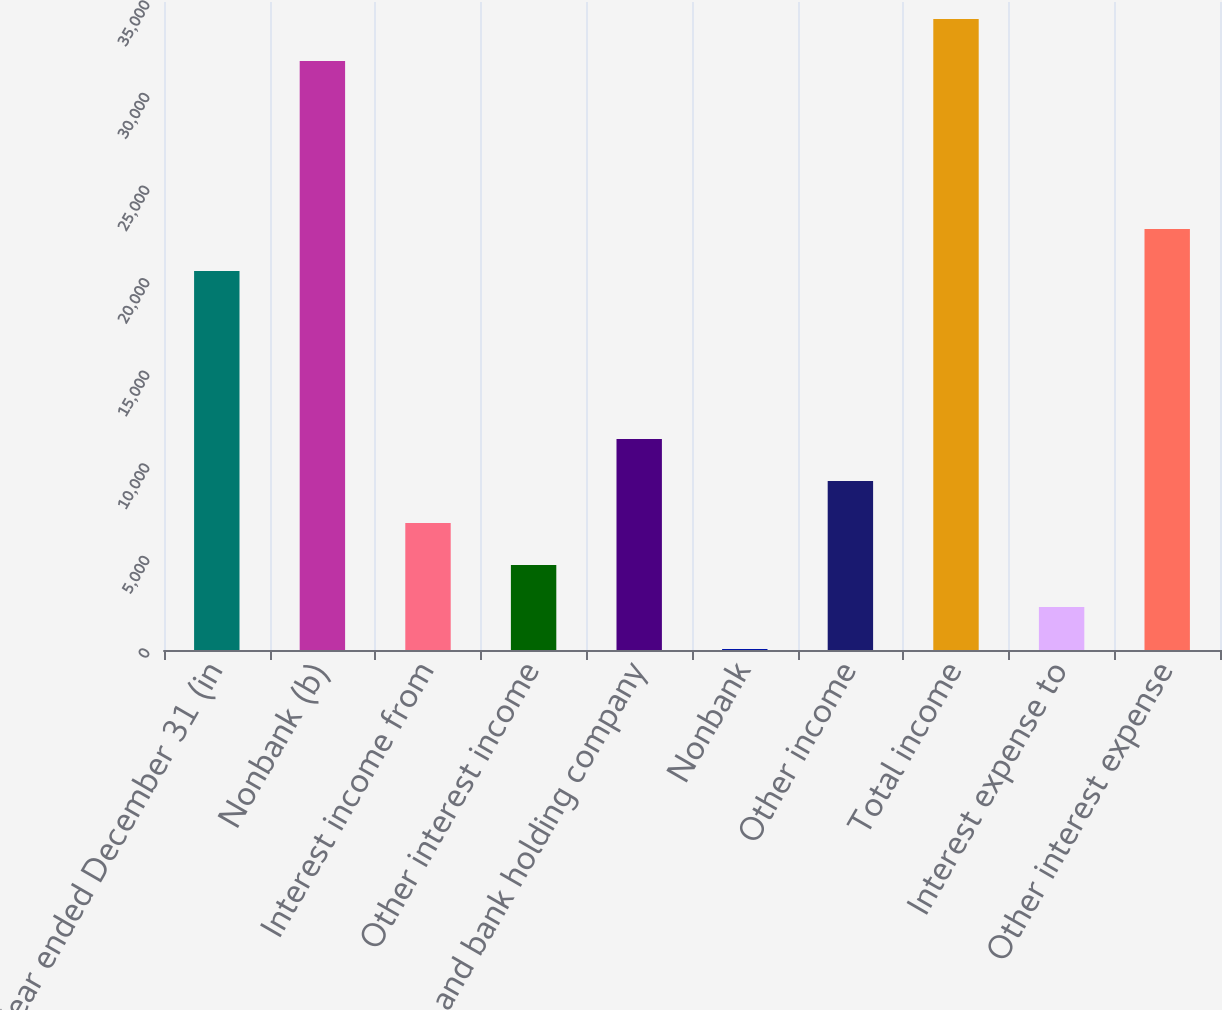<chart> <loc_0><loc_0><loc_500><loc_500><bar_chart><fcel>Year ended December 31 (in<fcel>Nonbank (b)<fcel>Interest income from<fcel>Other interest income<fcel>Bank and bank holding company<fcel>Nonbank<fcel>Other income<fcel>Total income<fcel>Interest expense to<fcel>Other interest expense<nl><fcel>20466.7<fcel>31808.2<fcel>6856.9<fcel>4588.6<fcel>11393.5<fcel>52<fcel>9125.2<fcel>34076.5<fcel>2320.3<fcel>22735<nl></chart> 